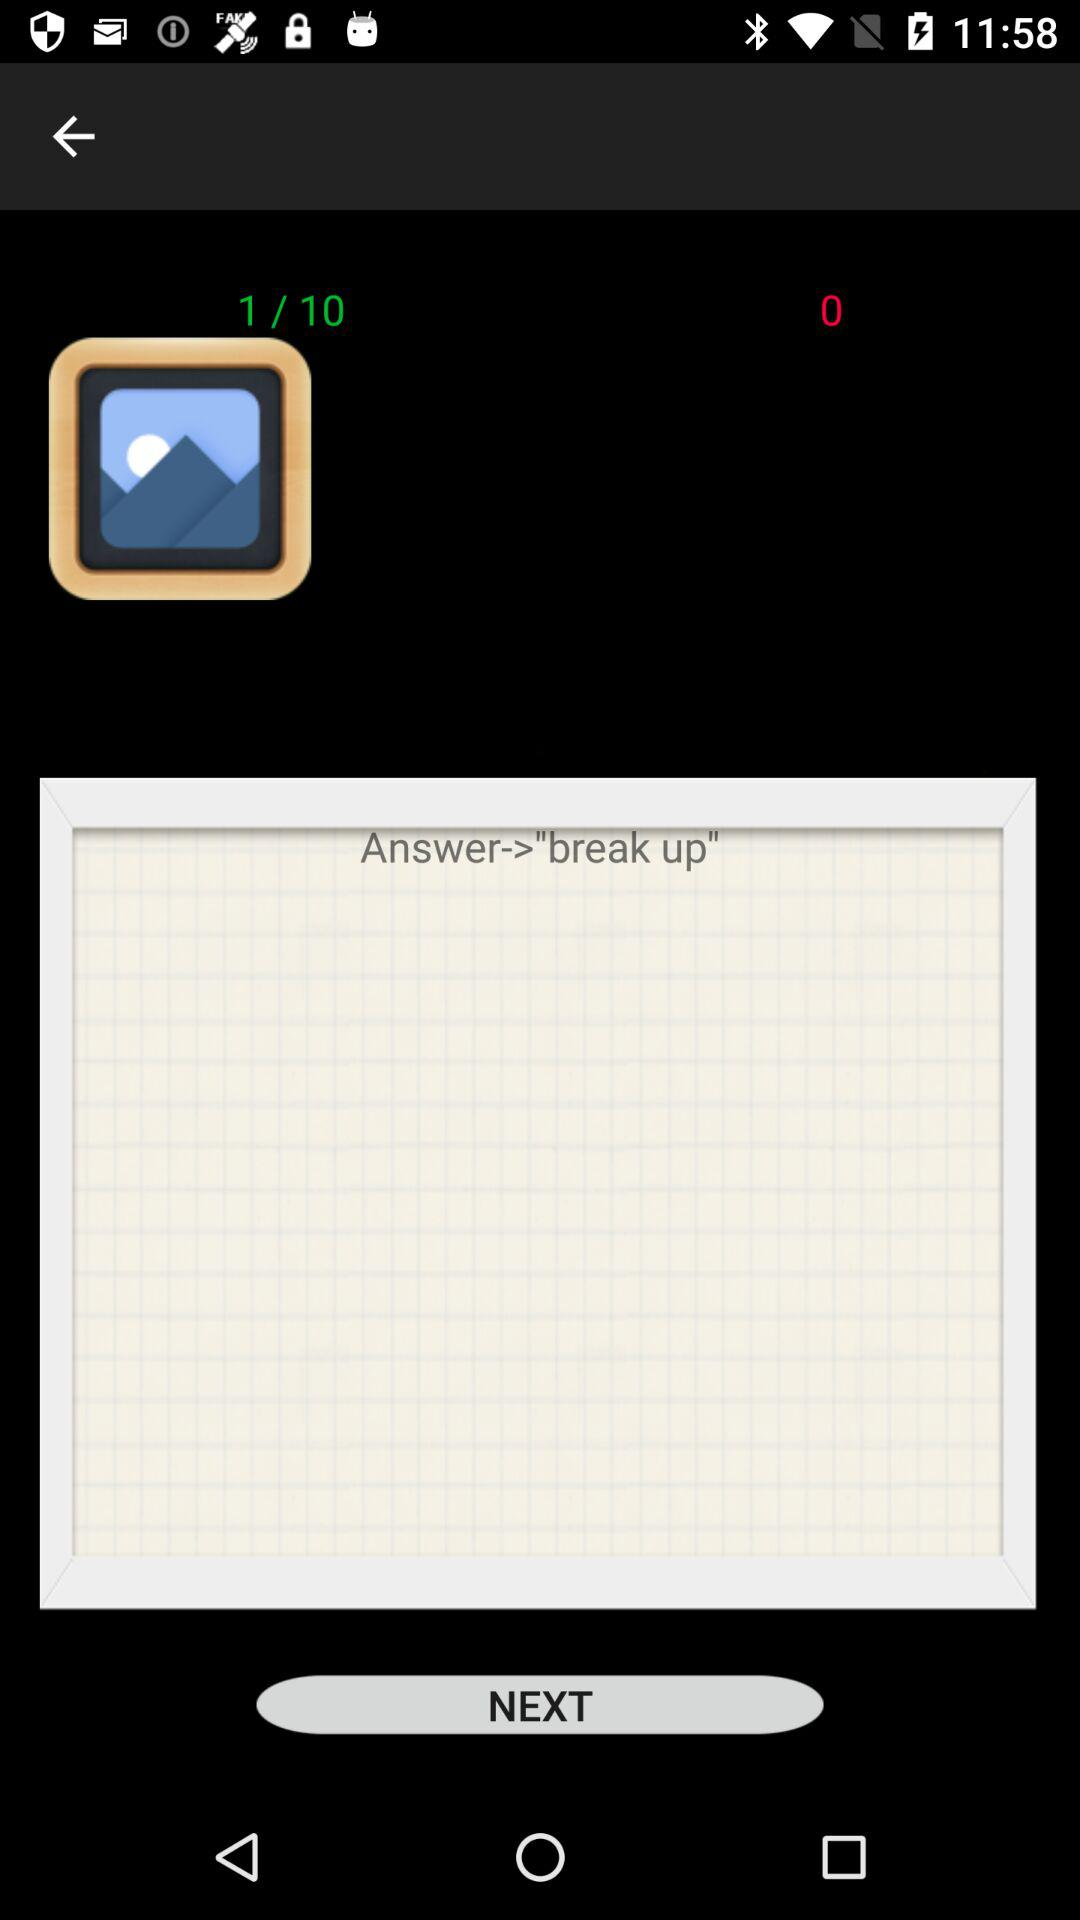How many more steps are there to complete the task?
Answer the question using a single word or phrase. 9 